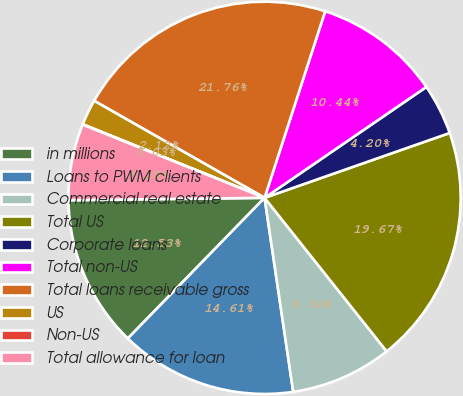Convert chart. <chart><loc_0><loc_0><loc_500><loc_500><pie_chart><fcel>in millions<fcel>Loans to PWM clients<fcel>Commercial real estate<fcel>Total US<fcel>Corporate loans<fcel>Total non-US<fcel>Total loans receivable gross<fcel>US<fcel>Non-US<fcel>Total allowance for loan<nl><fcel>12.53%<fcel>14.61%<fcel>8.36%<fcel>19.67%<fcel>4.2%<fcel>10.44%<fcel>21.76%<fcel>2.12%<fcel>0.03%<fcel>6.28%<nl></chart> 